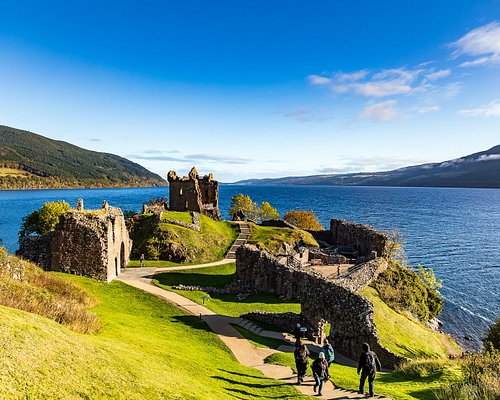If a film were to be shot here, what genre would best suit this location? The evocative ruins of Urquhart Castle and the mysterious Loch Ness create the perfect setting for a historical drama or a fantasy film. Imagine an epic tale set against the backdrop of medieval conflicts, bringing to life the storied past of the castle. Alternatively, the castle's mysterious vibe and the legend of the Loch Ness Monster create the ideal atmosphere for a fantasy film, filled with mythical creatures, heroic battles, and ancient magic. The breathtaking natural scenery would provide stunning visuals, enhancing the film's immersive experience. 